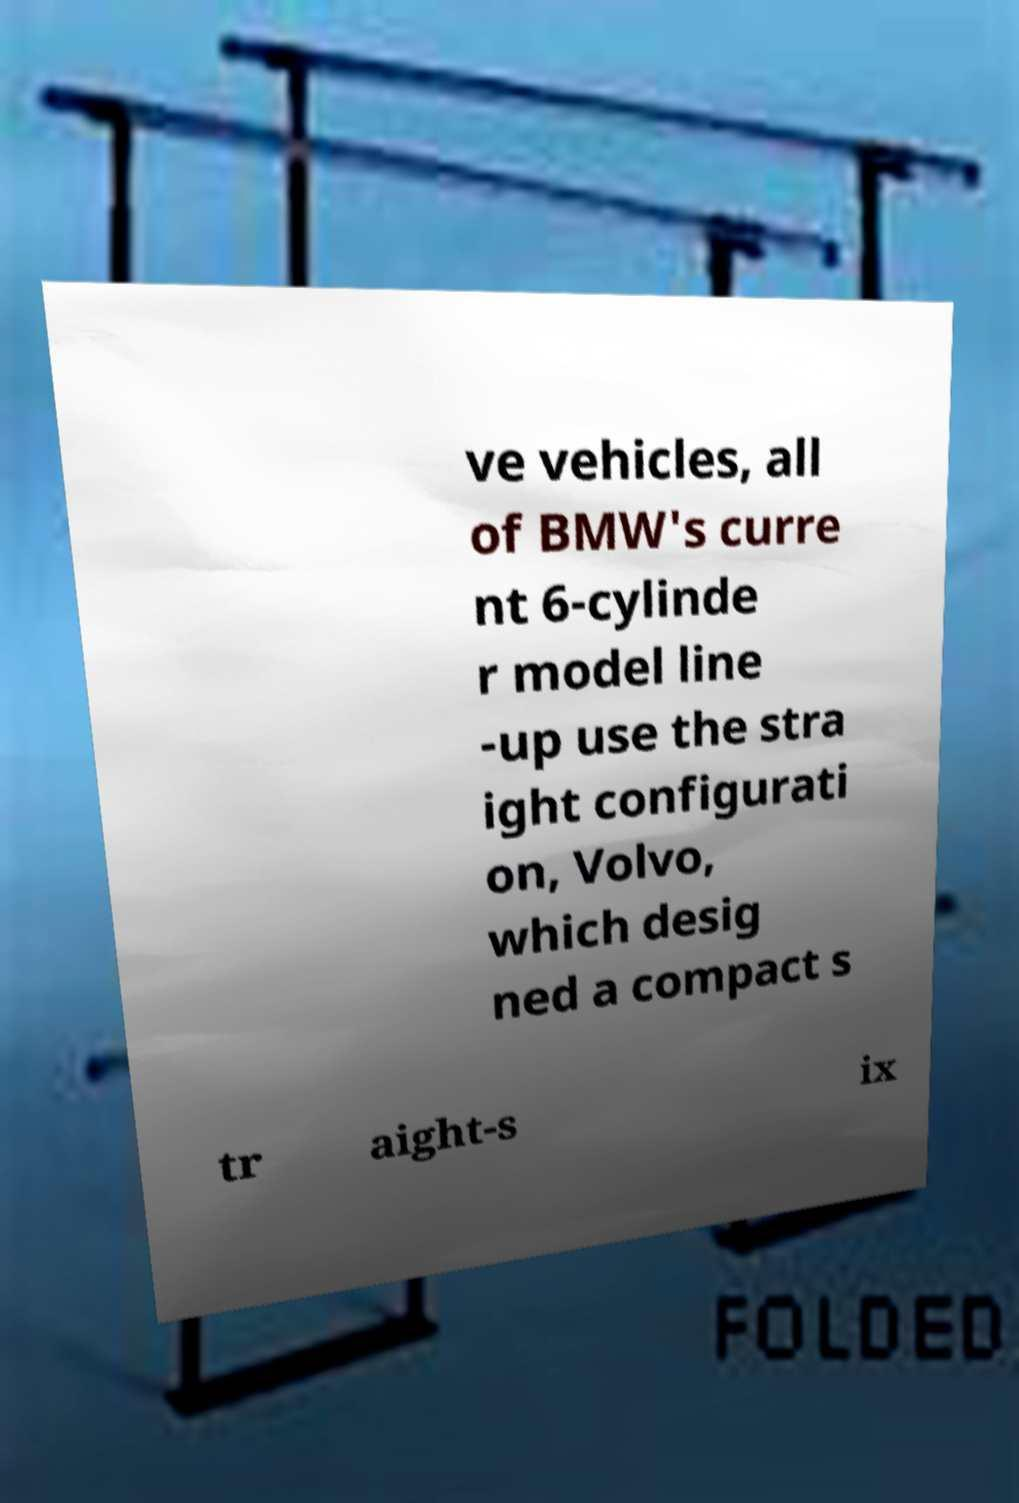I need the written content from this picture converted into text. Can you do that? ve vehicles, all of BMW's curre nt 6-cylinde r model line -up use the stra ight configurati on, Volvo, which desig ned a compact s tr aight-s ix 